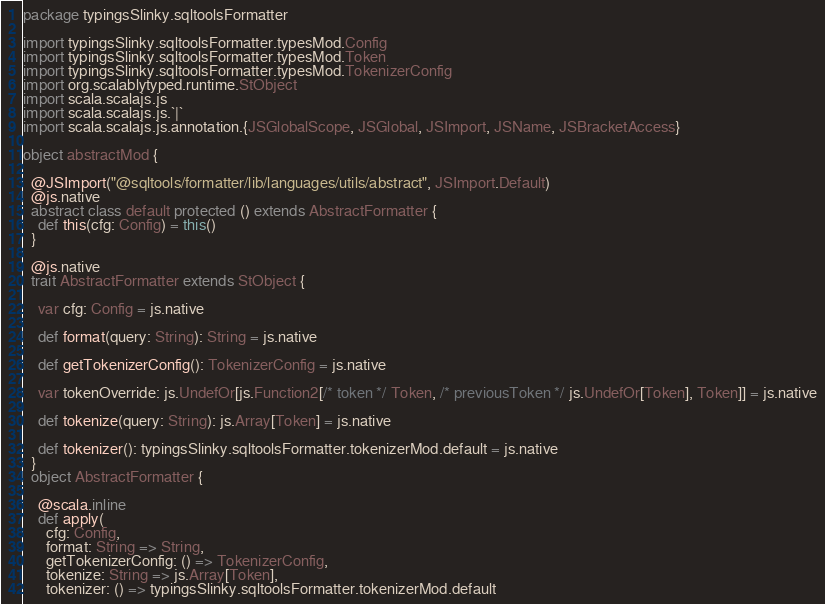Convert code to text. <code><loc_0><loc_0><loc_500><loc_500><_Scala_>package typingsSlinky.sqltoolsFormatter

import typingsSlinky.sqltoolsFormatter.typesMod.Config
import typingsSlinky.sqltoolsFormatter.typesMod.Token
import typingsSlinky.sqltoolsFormatter.typesMod.TokenizerConfig
import org.scalablytyped.runtime.StObject
import scala.scalajs.js
import scala.scalajs.js.`|`
import scala.scalajs.js.annotation.{JSGlobalScope, JSGlobal, JSImport, JSName, JSBracketAccess}

object abstractMod {
  
  @JSImport("@sqltools/formatter/lib/languages/utils/abstract", JSImport.Default)
  @js.native
  abstract class default protected () extends AbstractFormatter {
    def this(cfg: Config) = this()
  }
  
  @js.native
  trait AbstractFormatter extends StObject {
    
    var cfg: Config = js.native
    
    def format(query: String): String = js.native
    
    def getTokenizerConfig(): TokenizerConfig = js.native
    
    var tokenOverride: js.UndefOr[js.Function2[/* token */ Token, /* previousToken */ js.UndefOr[Token], Token]] = js.native
    
    def tokenize(query: String): js.Array[Token] = js.native
    
    def tokenizer(): typingsSlinky.sqltoolsFormatter.tokenizerMod.default = js.native
  }
  object AbstractFormatter {
    
    @scala.inline
    def apply(
      cfg: Config,
      format: String => String,
      getTokenizerConfig: () => TokenizerConfig,
      tokenize: String => js.Array[Token],
      tokenizer: () => typingsSlinky.sqltoolsFormatter.tokenizerMod.default</code> 